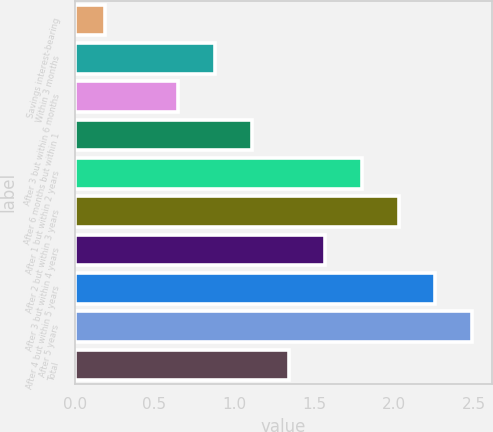Convert chart to OTSL. <chart><loc_0><loc_0><loc_500><loc_500><bar_chart><fcel>Savings interest-bearing<fcel>Within 3 months<fcel>After 3 but within 6 months<fcel>After 6 months but within 1<fcel>After 1 but within 2 years<fcel>After 2 but within 3 years<fcel>After 3 but within 4 years<fcel>After 4 but within 5 years<fcel>After 5 years<fcel>Total<nl><fcel>0.19<fcel>0.88<fcel>0.65<fcel>1.11<fcel>1.8<fcel>2.03<fcel>1.57<fcel>2.26<fcel>2.49<fcel>1.34<nl></chart> 